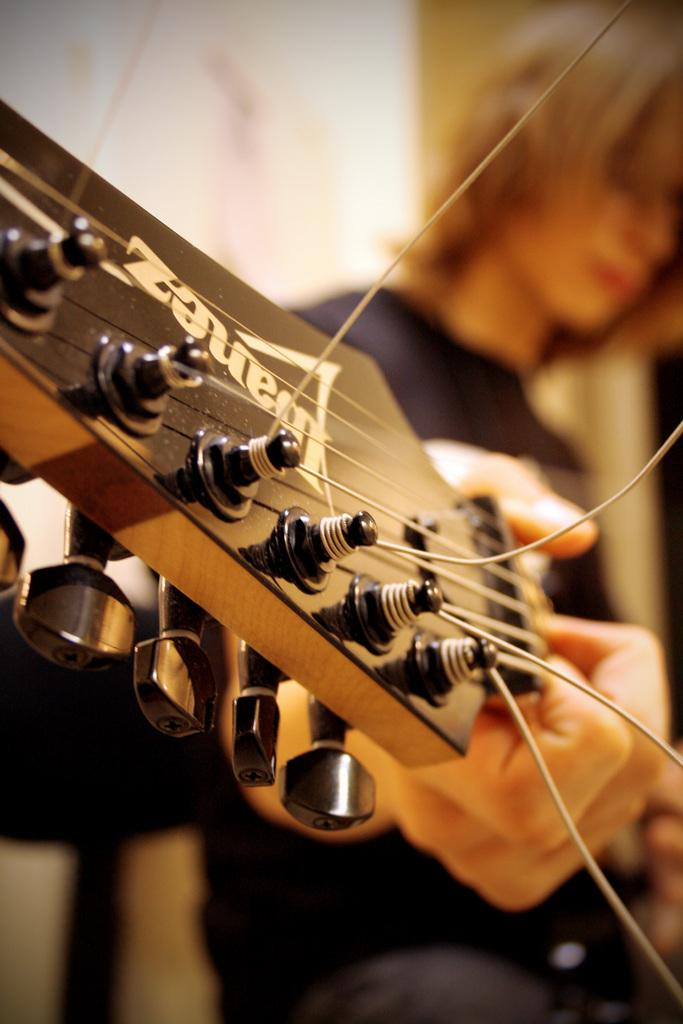Who is present in the image? There is a man in the image. What is the man wearing? The man is wearing a black T-shirt. What object can be seen in the image besides the man? There is a guitar in the image. What part of the guitar can be seen in the image? The guitar strings are visible in the image. What is the man doing with the guitar? A person's hand is playing the guitar. What type of disease is the man suffering from in the image? There is no indication in the image that the man is suffering from any disease. What record is the man listening to while playing the guitar? There is no record present in the image, and it does not show the man listening to any music. 